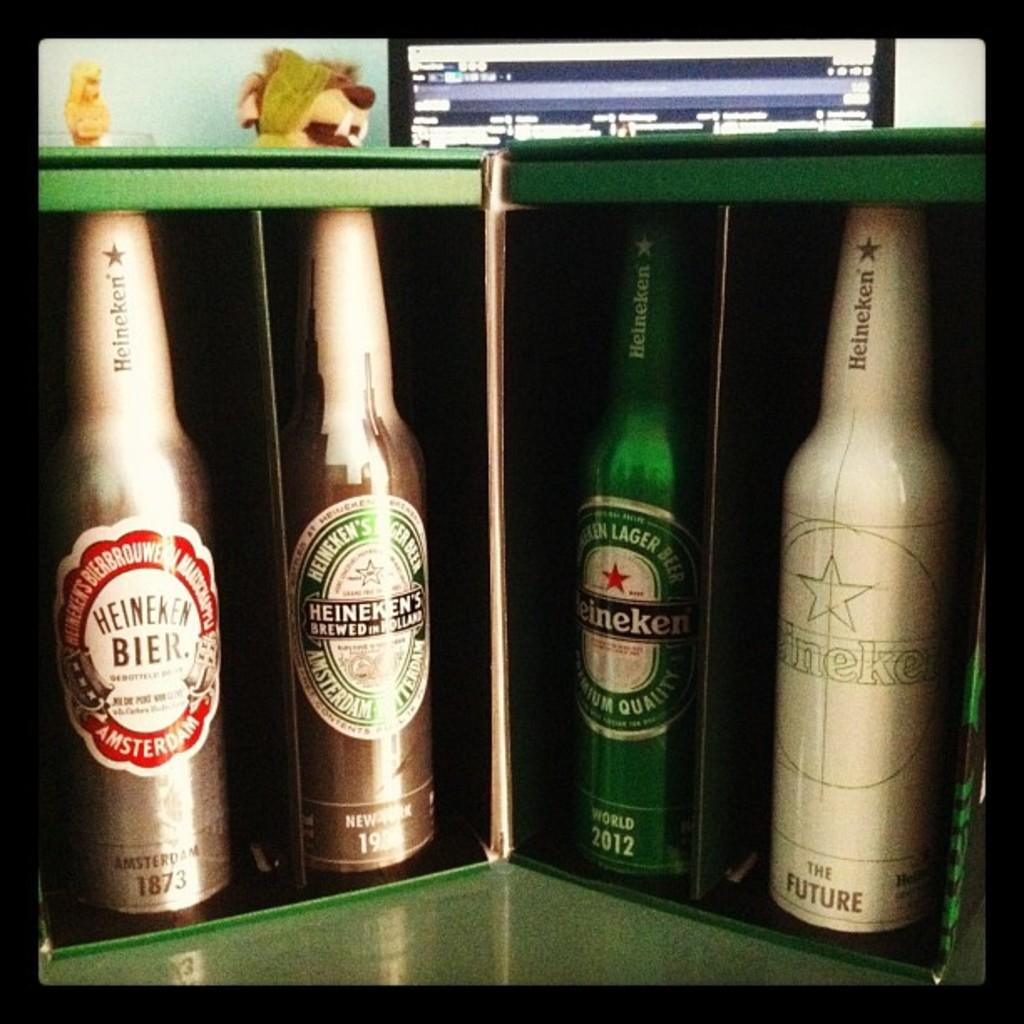<image>
Create a compact narrative representing the image presented. Four bottles of different colors with the brand of heineken on each of them. 